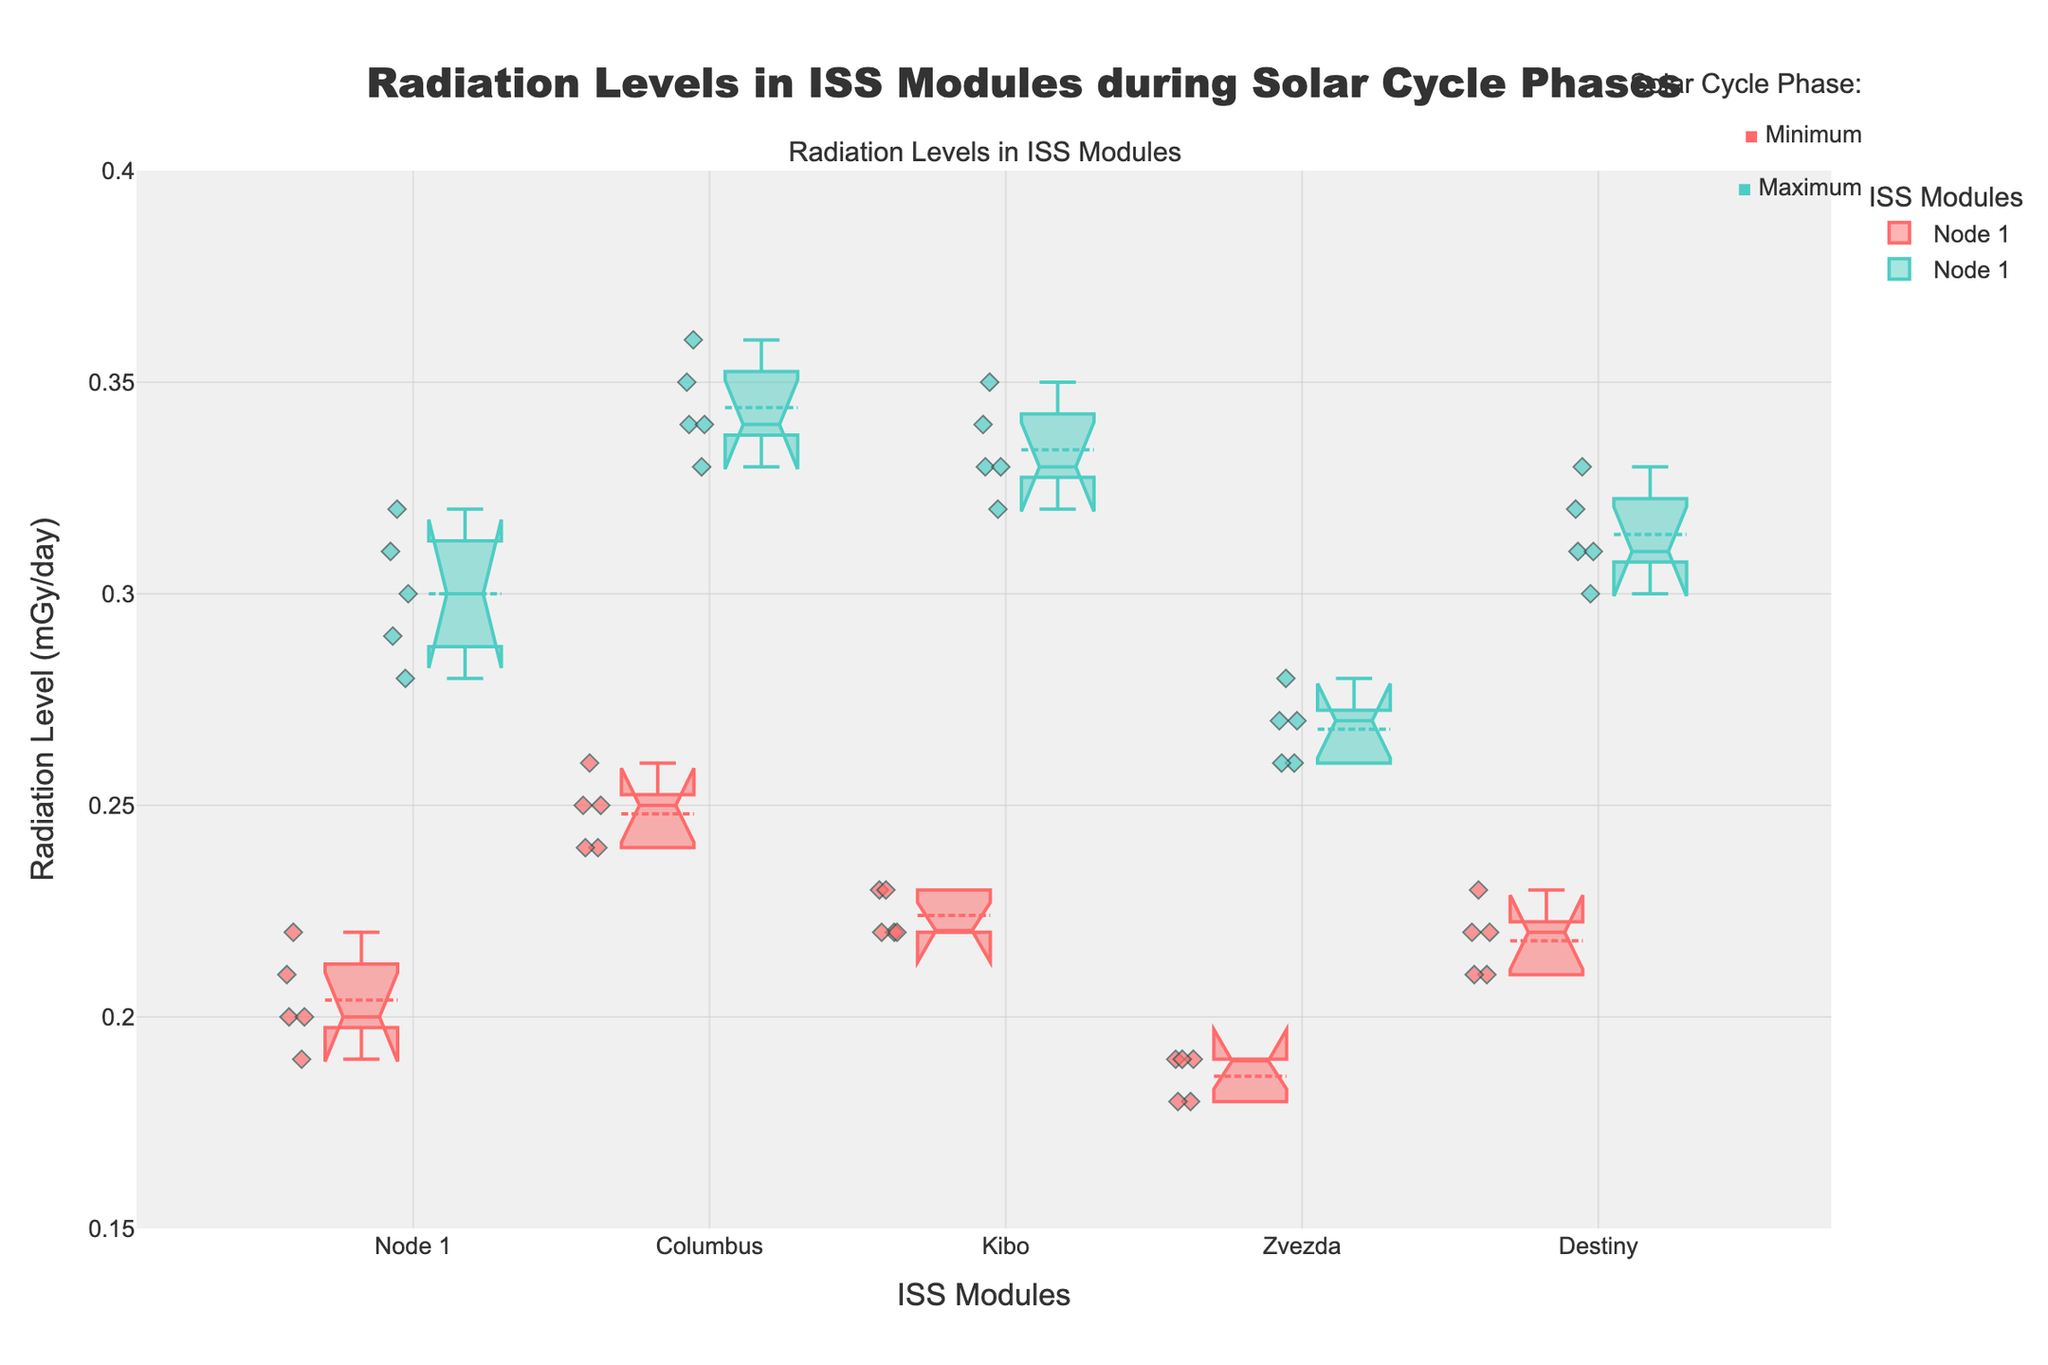What's the title of the plot? The title of the plot is "Radiation Levels in ISS Modules during Solar Cycle Phases" which can be directly observed at the top of the figure.
Answer: Radiation Levels in ISS Modules during Solar Cycle Phases How many different ISS modules are represented in the plot? Each module has its name shown in the x-axis labels, and there are five distinct labels: Node 1, Columbus, Kibo, Zvezda, and Destiny.
Answer: 5 In which solar cycle phase does Kibo module have the highest radiation level? Look at the notched box plot for Kibo module. The highest radiation levels are in the data points colored to represent the 'Maximum' solar cycle phase.
Answer: Maximum What is the median radiation level for Destiny module during the Maximum solar cycle phase? In the notched box plot for Destiny module under 'Maximum' phase, the central horizontal line represents the median value.
Answer: 0.31 mGy/day Which module has the lowest range of radiation levels during the Minimum solar cycle phase? The range can be determined by subtracting the lowest whisker value from the highest whisker value in each notched box plot. The Zvezda module has the smallest range for the Minimum phase.
Answer: Zvezda Compare the median radiation levels of Node 1 and Columbus modules during the Minimum solar cycle phase. Which module has a higher median? Look at the central horizontal lines in the notched box plots of Node 1 and Columbus for the Minimum phase. Columbus has a higher median.
Answer: Columbus What is the interquartile range (IQR) of the radiation level in the Node 1 module during the Maximum solar cycle phase? The IQR is the difference between the third quartile (upper edge of the box) and the first quartile (lower edge of the box) in the notched box plot. For Node 1 during Maximum phase, estimate these values and subtract: approximately 0.31 - 0.29.
Answer: 0.02 mGy/day Do any modules show an overlap in the notched area, indicating that their medians are not significantly different? If so, which ones? The notched areas of each box indicate the confidence intervals for the medians. If notches of different boxes overlap, their medians are not significantly different. Analyze the notched boxes to find overlaps.
Answer: Node 1 and Destiny (for example, during the Maximum phase) 